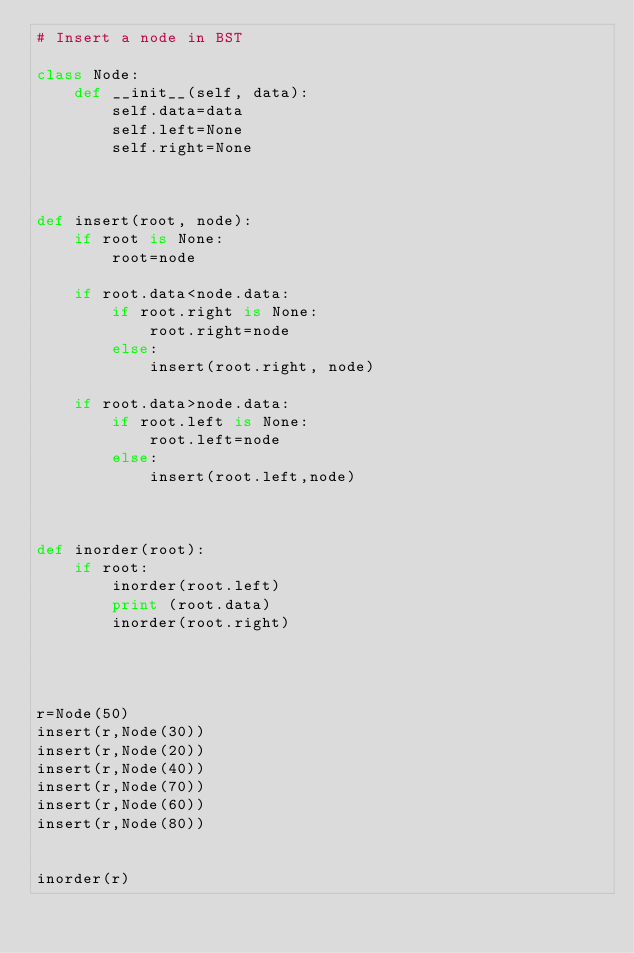<code> <loc_0><loc_0><loc_500><loc_500><_Python_># Insert a node in BST

class Node:
    def __init__(self, data):
        self.data=data
        self.left=None
        self.right=None



def insert(root, node):
    if root is None:
        root=node

    if root.data<node.data:
        if root.right is None:
            root.right=node
        else:
            insert(root.right, node)

    if root.data>node.data:
        if root.left is None:
            root.left=node
        else:
            insert(root.left,node)



def inorder(root):
    if root:
        inorder(root.left)
        print (root.data)
        inorder(root.right)




r=Node(50)
insert(r,Node(30))
insert(r,Node(20))
insert(r,Node(40))
insert(r,Node(70))
insert(r,Node(60))
insert(r,Node(80))


inorder(r)

</code> 